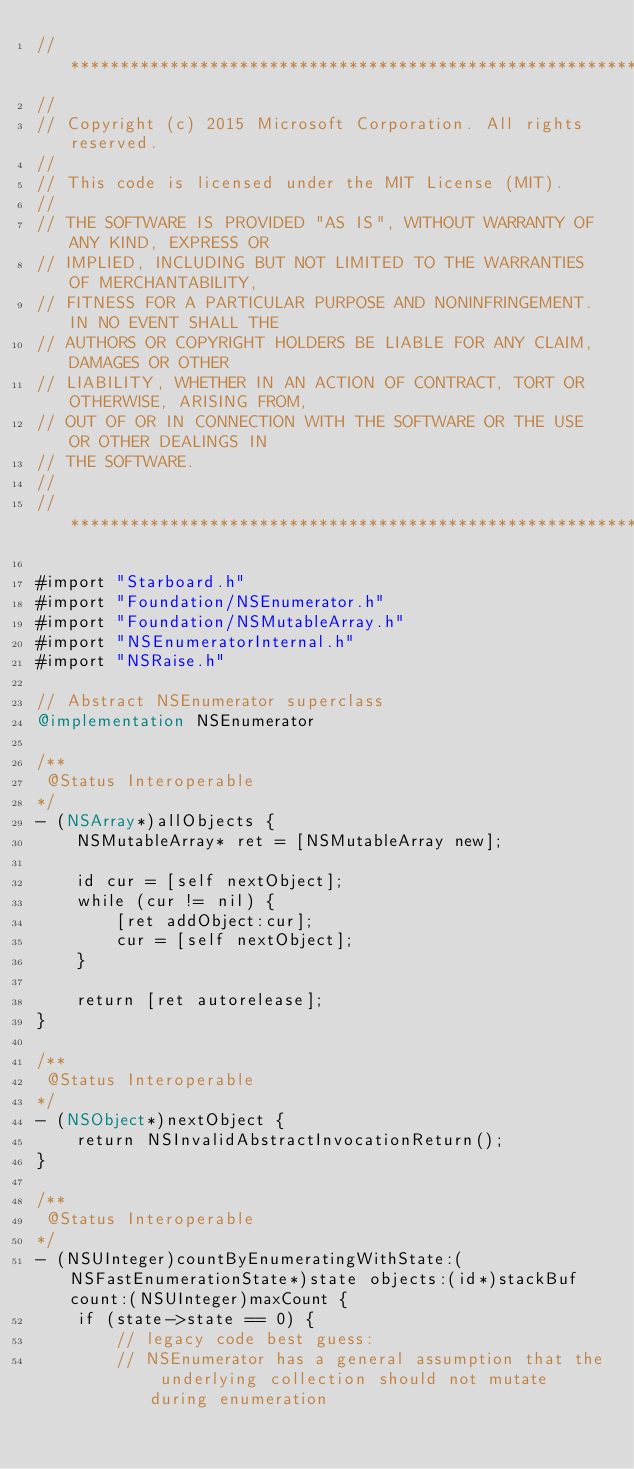Convert code to text. <code><loc_0><loc_0><loc_500><loc_500><_ObjectiveC_>//******************************************************************************
//
// Copyright (c) 2015 Microsoft Corporation. All rights reserved.
//
// This code is licensed under the MIT License (MIT).
//
// THE SOFTWARE IS PROVIDED "AS IS", WITHOUT WARRANTY OF ANY KIND, EXPRESS OR
// IMPLIED, INCLUDING BUT NOT LIMITED TO THE WARRANTIES OF MERCHANTABILITY,
// FITNESS FOR A PARTICULAR PURPOSE AND NONINFRINGEMENT. IN NO EVENT SHALL THE
// AUTHORS OR COPYRIGHT HOLDERS BE LIABLE FOR ANY CLAIM, DAMAGES OR OTHER
// LIABILITY, WHETHER IN AN ACTION OF CONTRACT, TORT OR OTHERWISE, ARISING FROM,
// OUT OF OR IN CONNECTION WITH THE SOFTWARE OR THE USE OR OTHER DEALINGS IN
// THE SOFTWARE.
//
//******************************************************************************

#import "Starboard.h"
#import "Foundation/NSEnumerator.h"
#import "Foundation/NSMutableArray.h"
#import "NSEnumeratorInternal.h"
#import "NSRaise.h"

// Abstract NSEnumerator superclass
@implementation NSEnumerator

/**
 @Status Interoperable
*/
- (NSArray*)allObjects {
    NSMutableArray* ret = [NSMutableArray new];

    id cur = [self nextObject];
    while (cur != nil) {
        [ret addObject:cur];
        cur = [self nextObject];
    }

    return [ret autorelease];
}

/**
 @Status Interoperable
*/
- (NSObject*)nextObject {
    return NSInvalidAbstractInvocationReturn();
}

/**
 @Status Interoperable
*/
- (NSUInteger)countByEnumeratingWithState:(NSFastEnumerationState*)state objects:(id*)stackBuf count:(NSUInteger)maxCount {
    if (state->state == 0) {
        // legacy code best guess:
        // NSEnumerator has a general assumption that the underlying collection should not mutate during enumeration</code> 